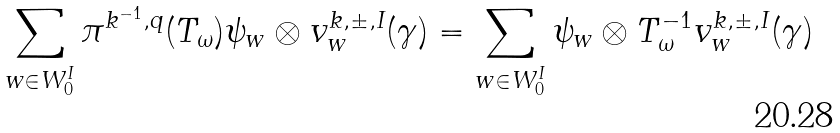<formula> <loc_0><loc_0><loc_500><loc_500>\sum _ { w \in W _ { 0 } ^ { I } } \pi ^ { k ^ { - 1 } , q } ( T _ { \omega } ) \psi _ { w } \otimes v _ { w } ^ { k , \pm , I } ( \gamma ) = \sum _ { w \in W _ { 0 } ^ { I } } \psi _ { w } \otimes T _ { \omega } ^ { - 1 } v _ { w } ^ { k , \pm , I } ( \gamma )</formula> 